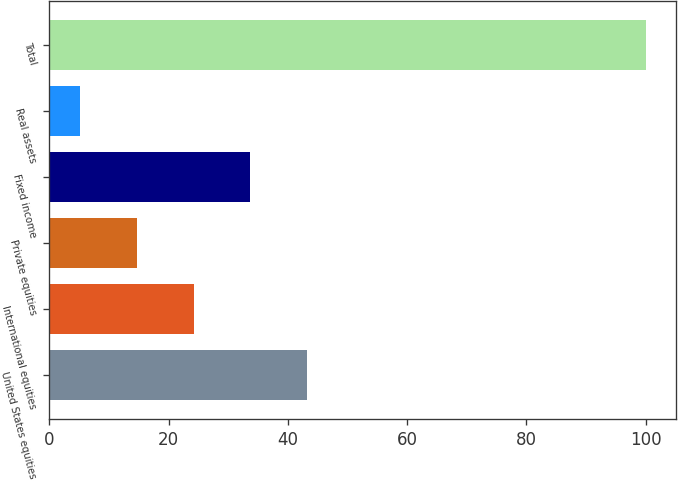Convert chart. <chart><loc_0><loc_0><loc_500><loc_500><bar_chart><fcel>United States equities<fcel>International equities<fcel>Private equities<fcel>Fixed income<fcel>Real assets<fcel>Total<nl><fcel>43.12<fcel>24.16<fcel>14.68<fcel>33.64<fcel>5.2<fcel>100<nl></chart> 